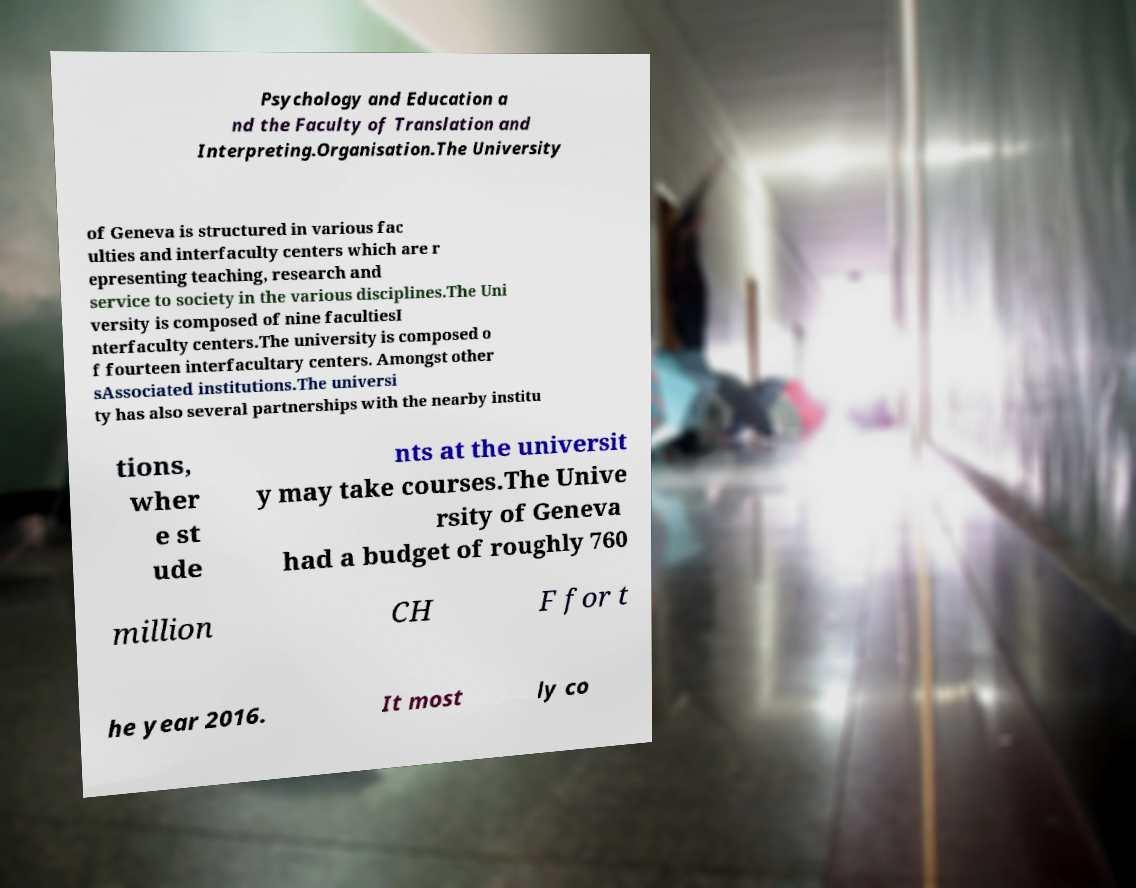Could you extract and type out the text from this image? Psychology and Education a nd the Faculty of Translation and Interpreting.Organisation.The University of Geneva is structured in various fac ulties and interfaculty centers which are r epresenting teaching, research and service to society in the various disciplines.The Uni versity is composed of nine facultiesI nterfaculty centers.The university is composed o f fourteen interfacultary centers. Amongst other sAssociated institutions.The universi ty has also several partnerships with the nearby institu tions, wher e st ude nts at the universit y may take courses.The Unive rsity of Geneva had a budget of roughly 760 million CH F for t he year 2016. It most ly co 